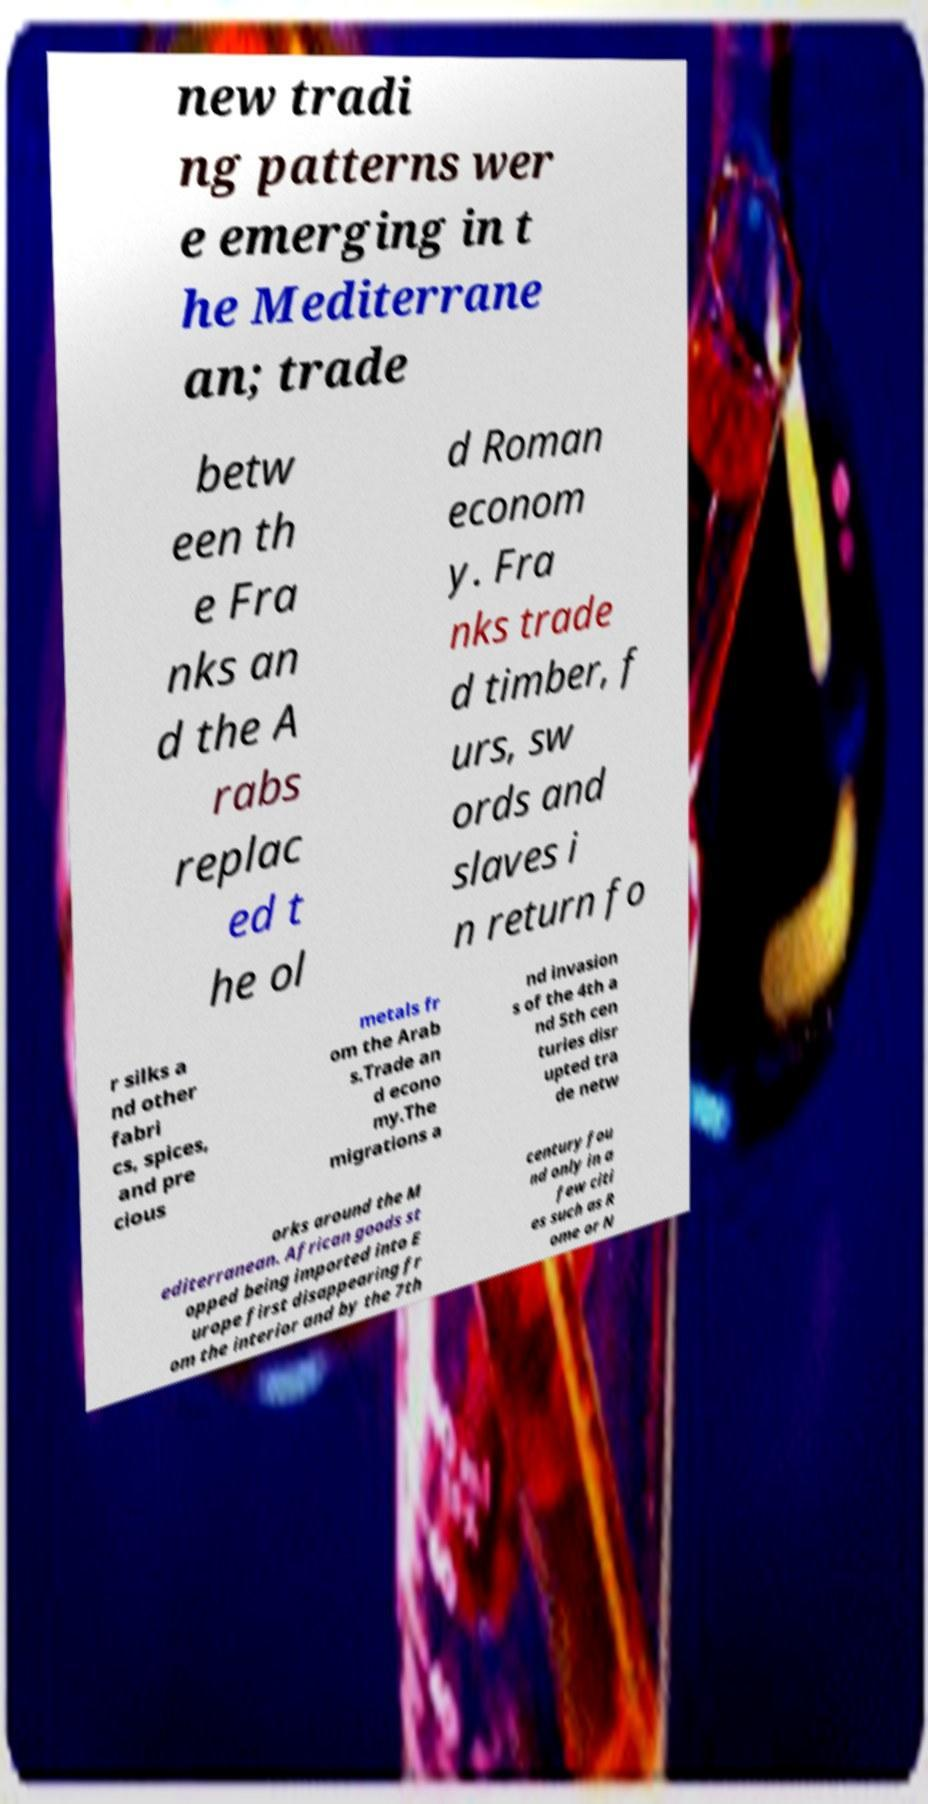Could you extract and type out the text from this image? new tradi ng patterns wer e emerging in t he Mediterrane an; trade betw een th e Fra nks an d the A rabs replac ed t he ol d Roman econom y. Fra nks trade d timber, f urs, sw ords and slaves i n return fo r silks a nd other fabri cs, spices, and pre cious metals fr om the Arab s.Trade an d econo my.The migrations a nd invasion s of the 4th a nd 5th cen turies disr upted tra de netw orks around the M editerranean. African goods st opped being imported into E urope first disappearing fr om the interior and by the 7th century fou nd only in a few citi es such as R ome or N 